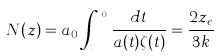<formula> <loc_0><loc_0><loc_500><loc_500>N ( z ) = a _ { 0 } \int _ { t _ { e } } ^ { t _ { 0 } } \frac { d t } { a ( t ) \zeta ( t ) } = \frac { 2 z _ { e } } { 3 k }</formula> 